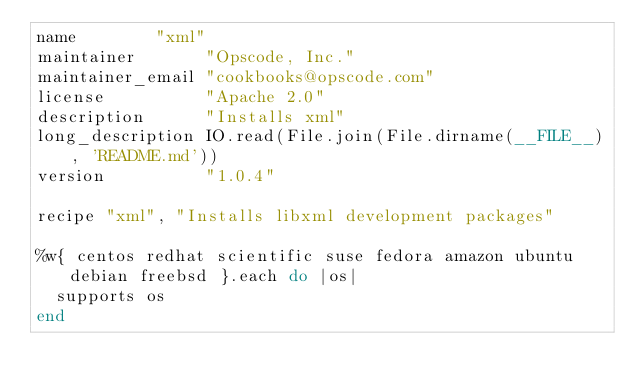Convert code to text. <code><loc_0><loc_0><loc_500><loc_500><_Ruby_>name        "xml"
maintainer       "Opscode, Inc."
maintainer_email "cookbooks@opscode.com"
license          "Apache 2.0"
description      "Installs xml"
long_description IO.read(File.join(File.dirname(__FILE__), 'README.md'))
version          "1.0.4"

recipe "xml", "Installs libxml development packages"

%w{ centos redhat scientific suse fedora amazon ubuntu debian freebsd }.each do |os|
  supports os
end
</code> 